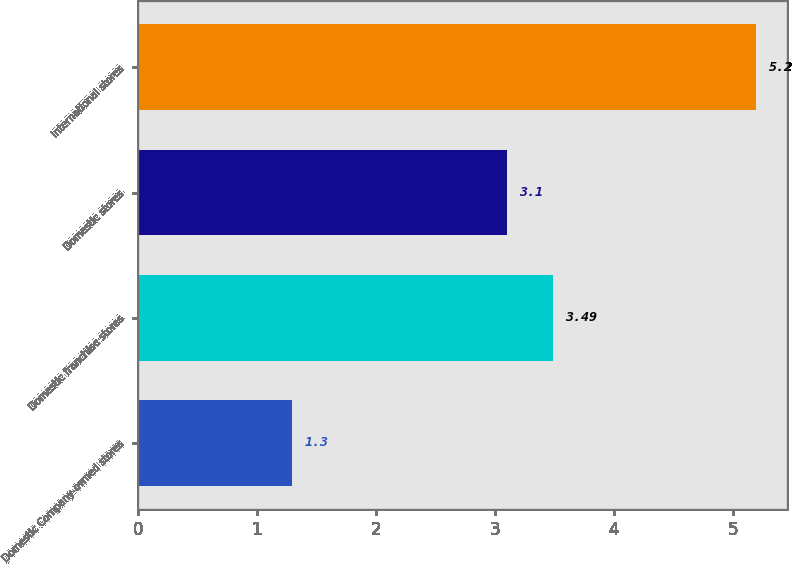<chart> <loc_0><loc_0><loc_500><loc_500><bar_chart><fcel>Domestic Company-owned stores<fcel>Domestic franchise stores<fcel>Domestic stores<fcel>International stores<nl><fcel>1.3<fcel>3.49<fcel>3.1<fcel>5.2<nl></chart> 